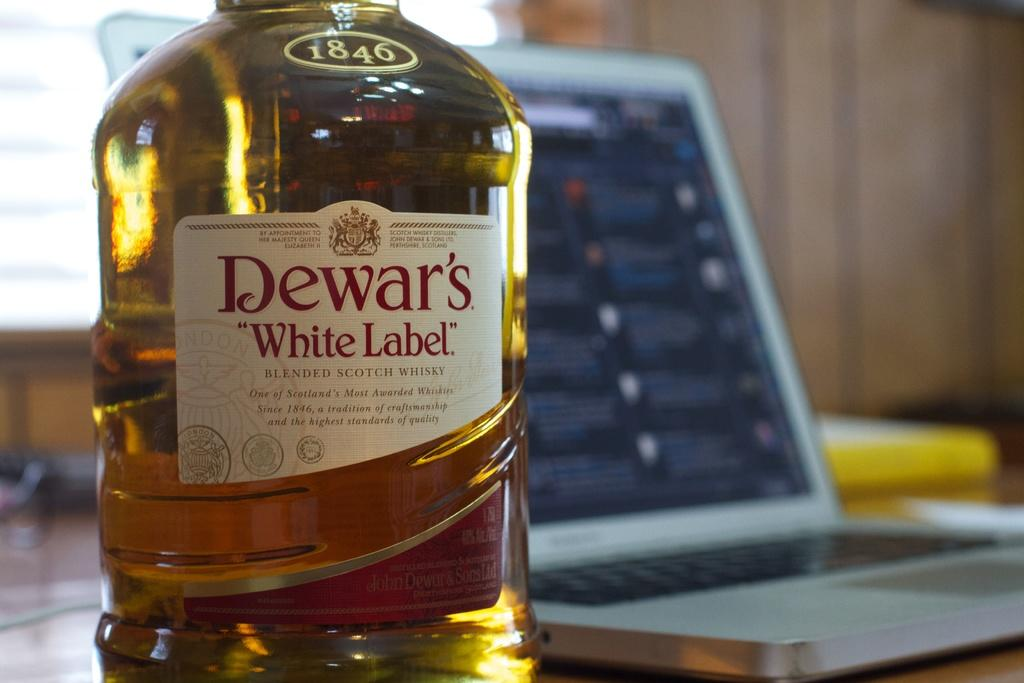<image>
Present a compact description of the photo's key features. A clear bottle of Dewar's white label scotch. 